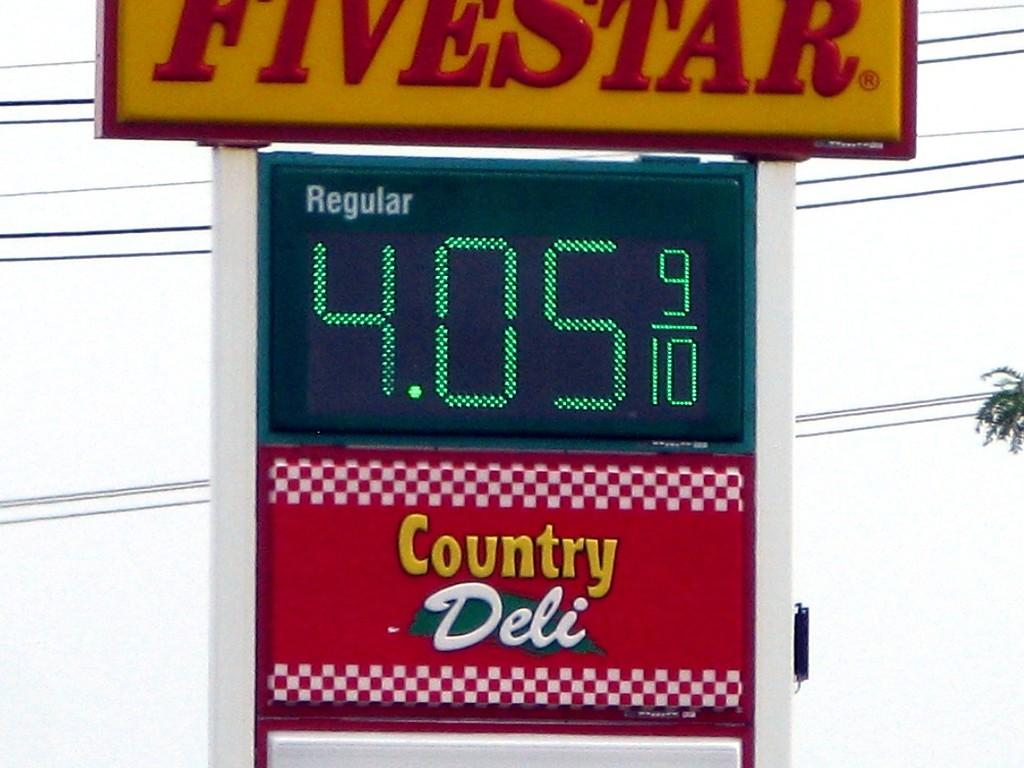<image>
Provide a brief description of the given image. A gas station named Fivestar with the price of Regular gasoline showing 4.05 and 9/10 in green electronic print along with Country Deli advertisement below. 